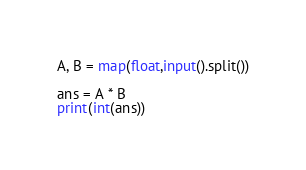<code> <loc_0><loc_0><loc_500><loc_500><_Python_>A, B = map(float,input().split())

ans = A * B
print(int(ans))

</code> 